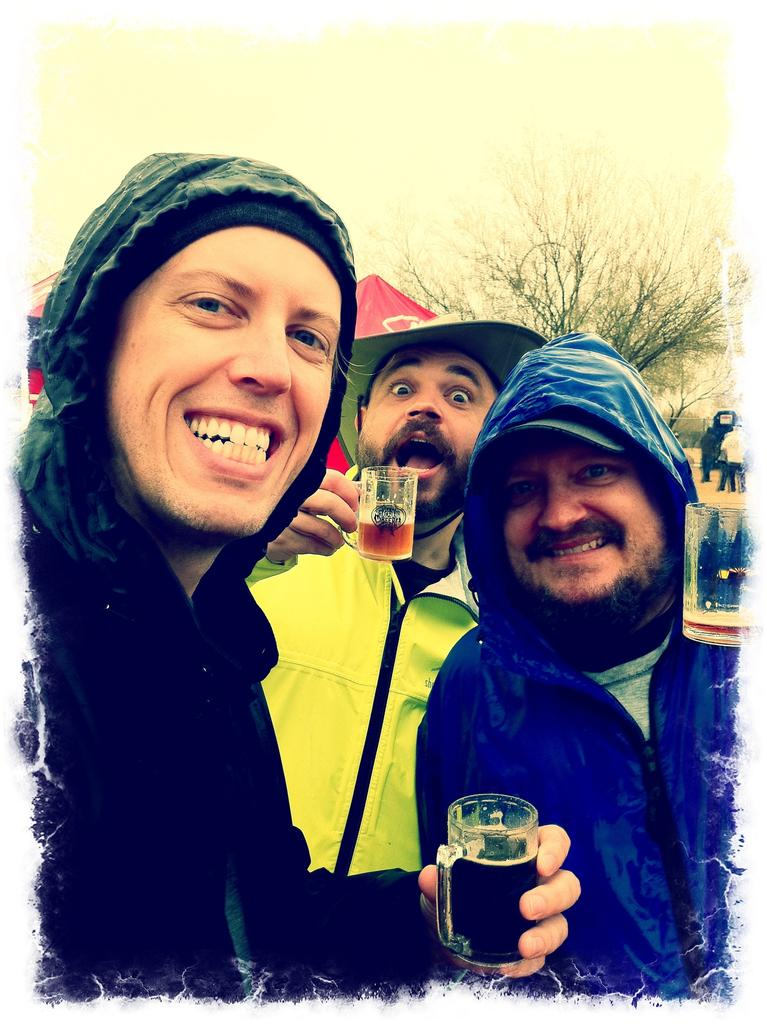How many people are in the image? There is a group of people in the image. What are the people in the image doing? The people are standing. What can be seen in the background of the image? There is a building, a tree, and the sky visible in the background of the image. What type of soup is being served in the image? There is no soup present in the image. Is there an arch visible in the image? There is no arch visible in the image. 